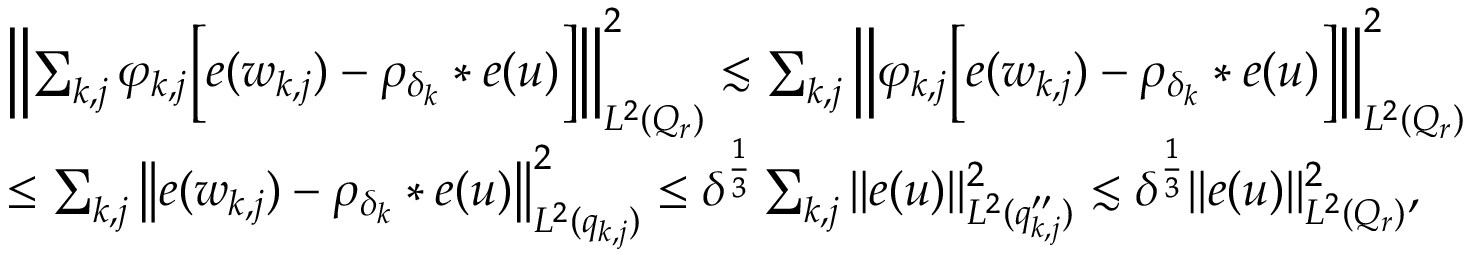<formula> <loc_0><loc_0><loc_500><loc_500>\begin{array} { r l } & { \left \| \sum _ { k , j } \varphi _ { k , j } \left [ e ( w _ { k , j } ) - \rho _ { \delta _ { k } } * e ( u ) \right ] \right \| _ { L ^ { 2 } ( Q _ { r } ) } ^ { 2 } \lesssim \sum _ { k , j } \left \| \varphi _ { k , j } \left [ e ( w _ { k , j } ) - \rho _ { \delta _ { k } } * e ( u ) \right ] \right \| _ { L ^ { 2 } ( Q _ { r } ) } ^ { 2 } } \\ & { \leq \sum _ { k , j } \left \| e ( w _ { k , j } ) - \rho _ { \delta _ { k } } * e ( u ) \right \| _ { L ^ { 2 } ( q _ { k , j } ) } ^ { 2 } \leq \delta ^ { \frac { 1 } { 3 } } \sum _ { k , j } \| e ( u ) \| _ { L ^ { 2 } ( q _ { k , j } ^ { \prime \prime } ) } ^ { 2 } \lesssim \delta ^ { \frac { 1 } { 3 } } \| e ( u ) \| _ { L ^ { 2 } ( Q _ { r } ) } ^ { 2 } , } \end{array}</formula> 